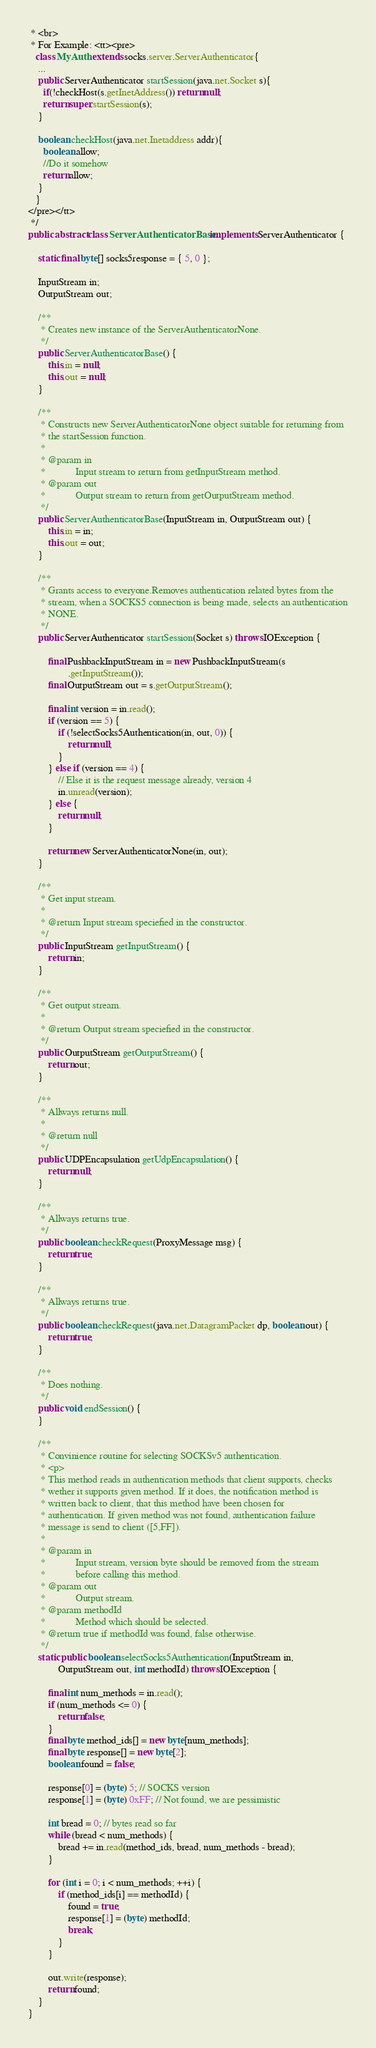Convert code to text. <code><loc_0><loc_0><loc_500><loc_500><_Java_> * <br>
 * For Example: <tt><pre>
   class MyAuth extends socks.server.ServerAuthenticator{
    ...
    public ServerAuthenticator startSession(java.net.Socket s){
      if(!checkHost(s.getInetAddress()) return null;
      return super.startSession(s);
    }

    boolean checkHost(java.net.Inetaddress addr){
      boolean allow;
      //Do it somehow
      return allow;
    }
   }
</pre></tt>
 */
public abstract class ServerAuthenticatorBase implements ServerAuthenticator {

	static final byte[] socks5response = { 5, 0 };

	InputStream in;
	OutputStream out;

	/**
	 * Creates new instance of the ServerAuthenticatorNone.
	 */
	public ServerAuthenticatorBase() {
		this.in = null;
		this.out = null;
	}

	/**
	 * Constructs new ServerAuthenticatorNone object suitable for returning from
	 * the startSession function.
	 * 
	 * @param in
	 *            Input stream to return from getInputStream method.
	 * @param out
	 *            Output stream to return from getOutputStream method.
	 */
	public ServerAuthenticatorBase(InputStream in, OutputStream out) {
		this.in = in;
		this.out = out;
	}

	/**
	 * Grants access to everyone.Removes authentication related bytes from the
	 * stream, when a SOCKS5 connection is being made, selects an authentication
	 * NONE.
	 */
	public ServerAuthenticator startSession(Socket s) throws IOException {

		final PushbackInputStream in = new PushbackInputStream(s
				.getInputStream());
		final OutputStream out = s.getOutputStream();

		final int version = in.read();
		if (version == 5) {
			if (!selectSocks5Authentication(in, out, 0)) {
				return null;
			}
		} else if (version == 4) {
			// Else it is the request message already, version 4
			in.unread(version);
		} else {
			return null;
		}

		return new ServerAuthenticatorNone(in, out);
	}

	/**
	 * Get input stream.
	 * 
	 * @return Input stream speciefied in the constructor.
	 */
	public InputStream getInputStream() {
		return in;
	}

	/**
	 * Get output stream.
	 * 
	 * @return Output stream speciefied in the constructor.
	 */
	public OutputStream getOutputStream() {
		return out;
	}

	/**
	 * Allways returns null.
	 * 
	 * @return null
	 */
	public UDPEncapsulation getUdpEncapsulation() {
		return null;
	}

	/**
	 * Allways returns true.
	 */
	public boolean checkRequest(ProxyMessage msg) {
		return true;
	}

	/**
	 * Allways returns true.
	 */
	public boolean checkRequest(java.net.DatagramPacket dp, boolean out) {
		return true;
	}

	/**
	 * Does nothing.
	 */
	public void endSession() {
	}

	/**
	 * Convinience routine for selecting SOCKSv5 authentication.
	 * <p>
	 * This method reads in authentication methods that client supports, checks
	 * wether it supports given method. If it does, the notification method is
	 * written back to client, that this method have been chosen for
	 * authentication. If given method was not found, authentication failure
	 * message is send to client ([5,FF]).
	 * 
	 * @param in
	 *            Input stream, version byte should be removed from the stream
	 *            before calling this method.
	 * @param out
	 *            Output stream.
	 * @param methodId
	 *            Method which should be selected.
	 * @return true if methodId was found, false otherwise.
	 */
	static public boolean selectSocks5Authentication(InputStream in,
			OutputStream out, int methodId) throws IOException {

		final int num_methods = in.read();
		if (num_methods <= 0) {
			return false;
		}
		final byte method_ids[] = new byte[num_methods];
		final byte response[] = new byte[2];
		boolean found = false;

		response[0] = (byte) 5; // SOCKS version
		response[1] = (byte) 0xFF; // Not found, we are pessimistic

		int bread = 0; // bytes read so far
		while (bread < num_methods) {
			bread += in.read(method_ids, bread, num_methods - bread);
		}

		for (int i = 0; i < num_methods; ++i) {
			if (method_ids[i] == methodId) {
				found = true;
				response[1] = (byte) methodId;
				break;
			}
		}

		out.write(response);
		return found;
	}
}
</code> 